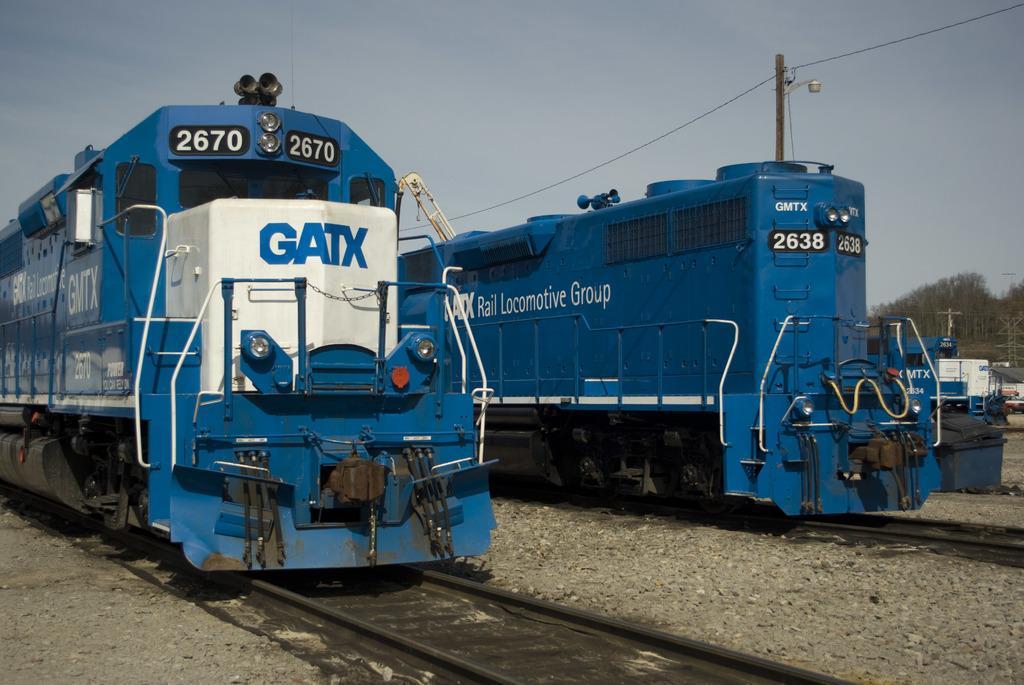Describe this image in one or two sentences. At the bottom of the image there are some tracks and stones. In the middle of the image there are some locomotives. Behind the locomotives there are some poles and trees. At the top of the image there are some clouds and sky. 